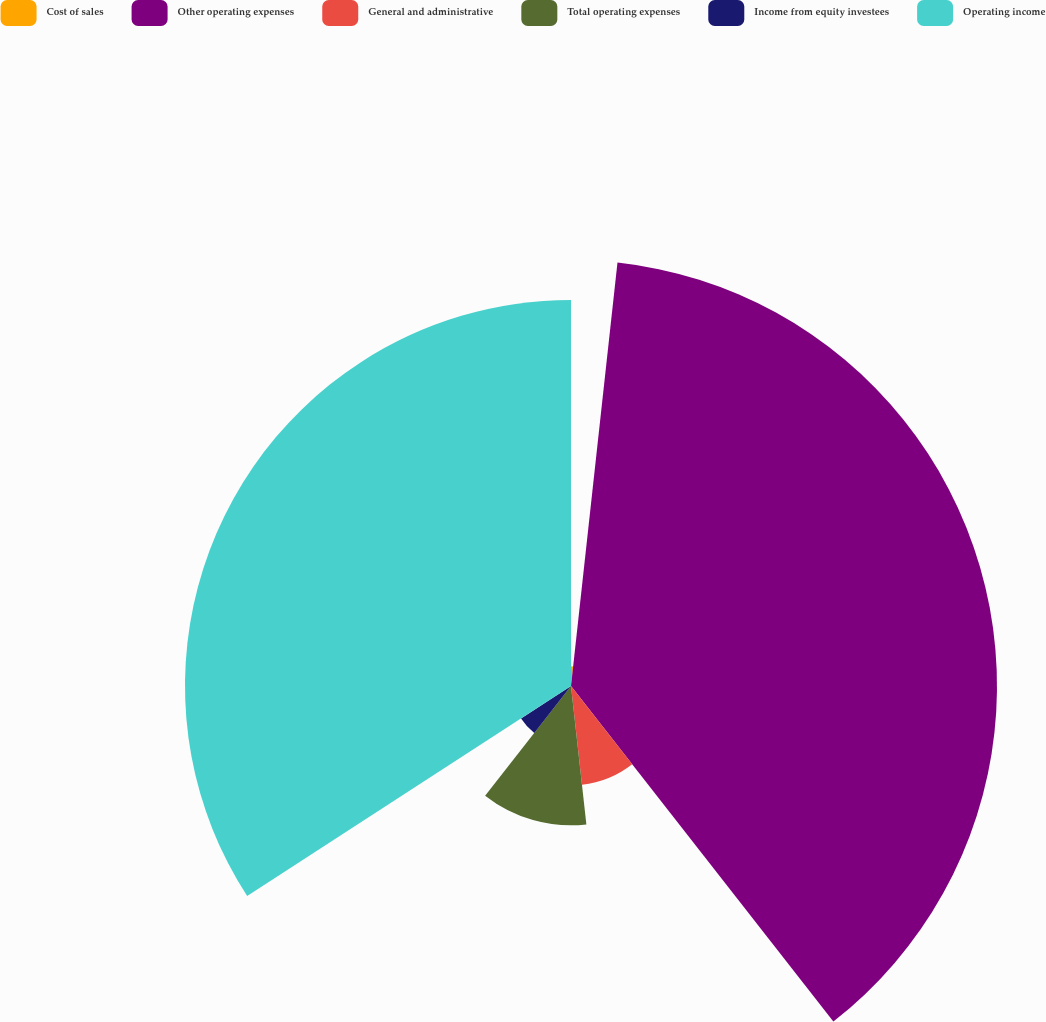Convert chart to OTSL. <chart><loc_0><loc_0><loc_500><loc_500><pie_chart><fcel>Cost of sales<fcel>Other operating expenses<fcel>General and administrative<fcel>Total operating expenses<fcel>Income from equity investees<fcel>Operating income<nl><fcel>1.74%<fcel>37.7%<fcel>8.8%<fcel>12.33%<fcel>5.27%<fcel>34.16%<nl></chart> 